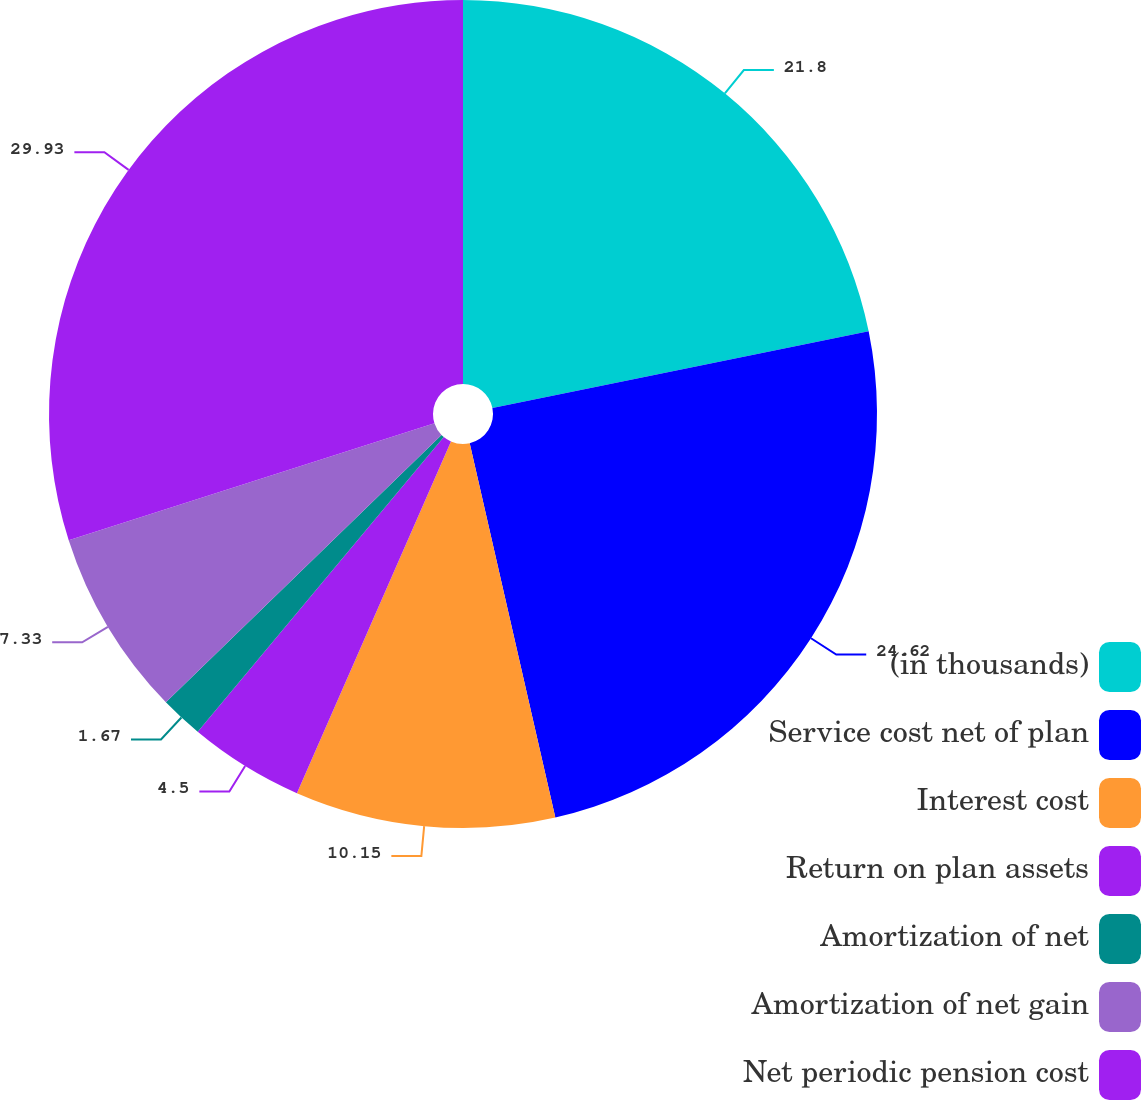<chart> <loc_0><loc_0><loc_500><loc_500><pie_chart><fcel>(in thousands)<fcel>Service cost net of plan<fcel>Interest cost<fcel>Return on plan assets<fcel>Amortization of net<fcel>Amortization of net gain<fcel>Net periodic pension cost<nl><fcel>21.8%<fcel>24.62%<fcel>10.15%<fcel>4.5%<fcel>1.67%<fcel>7.33%<fcel>29.93%<nl></chart> 